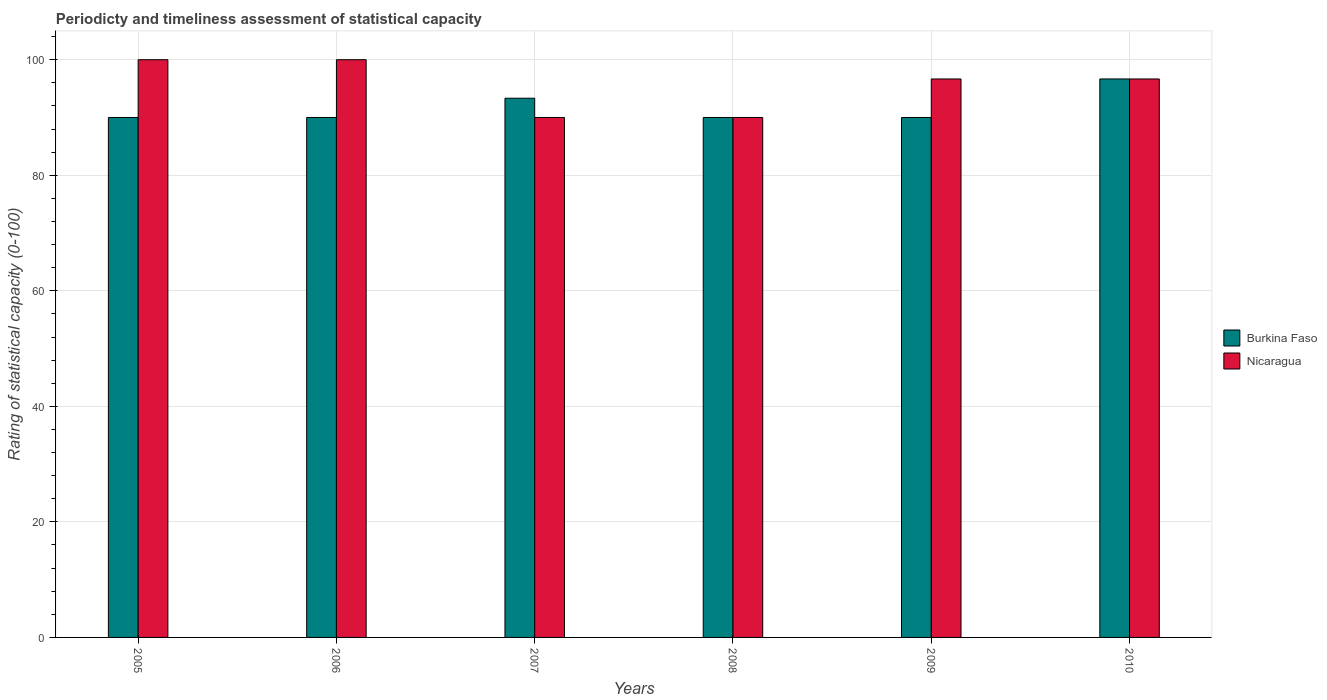Are the number of bars per tick equal to the number of legend labels?
Provide a short and direct response. Yes. Are the number of bars on each tick of the X-axis equal?
Keep it short and to the point. Yes. How many bars are there on the 1st tick from the right?
Offer a terse response. 2. What is the label of the 1st group of bars from the left?
Make the answer very short. 2005. What is the rating of statistical capacity in Burkina Faso in 2010?
Keep it short and to the point. 96.67. Across all years, what is the maximum rating of statistical capacity in Burkina Faso?
Ensure brevity in your answer.  96.67. Across all years, what is the minimum rating of statistical capacity in Nicaragua?
Keep it short and to the point. 90. What is the total rating of statistical capacity in Nicaragua in the graph?
Keep it short and to the point. 573.33. What is the difference between the rating of statistical capacity in Burkina Faso in 2005 and that in 2008?
Offer a very short reply. 0. What is the difference between the rating of statistical capacity in Burkina Faso in 2010 and the rating of statistical capacity in Nicaragua in 2009?
Make the answer very short. 0. What is the average rating of statistical capacity in Nicaragua per year?
Provide a short and direct response. 95.56. In the year 2008, what is the difference between the rating of statistical capacity in Nicaragua and rating of statistical capacity in Burkina Faso?
Give a very brief answer. 0. What is the difference between the highest and the second highest rating of statistical capacity in Nicaragua?
Provide a short and direct response. 0. What is the difference between the highest and the lowest rating of statistical capacity in Burkina Faso?
Ensure brevity in your answer.  6.67. In how many years, is the rating of statistical capacity in Nicaragua greater than the average rating of statistical capacity in Nicaragua taken over all years?
Ensure brevity in your answer.  4. Is the sum of the rating of statistical capacity in Nicaragua in 2008 and 2010 greater than the maximum rating of statistical capacity in Burkina Faso across all years?
Provide a succinct answer. Yes. What does the 1st bar from the left in 2008 represents?
Offer a terse response. Burkina Faso. What does the 1st bar from the right in 2005 represents?
Your response must be concise. Nicaragua. Are all the bars in the graph horizontal?
Keep it short and to the point. No. What is the difference between two consecutive major ticks on the Y-axis?
Provide a short and direct response. 20. Are the values on the major ticks of Y-axis written in scientific E-notation?
Your answer should be very brief. No. Does the graph contain any zero values?
Make the answer very short. No. Does the graph contain grids?
Provide a succinct answer. Yes. Where does the legend appear in the graph?
Your response must be concise. Center right. How are the legend labels stacked?
Provide a succinct answer. Vertical. What is the title of the graph?
Provide a succinct answer. Periodicty and timeliness assessment of statistical capacity. What is the label or title of the Y-axis?
Make the answer very short. Rating of statistical capacity (0-100). What is the Rating of statistical capacity (0-100) of Burkina Faso in 2005?
Your answer should be compact. 90. What is the Rating of statistical capacity (0-100) of Burkina Faso in 2006?
Provide a short and direct response. 90. What is the Rating of statistical capacity (0-100) of Nicaragua in 2006?
Your response must be concise. 100. What is the Rating of statistical capacity (0-100) of Burkina Faso in 2007?
Your answer should be very brief. 93.33. What is the Rating of statistical capacity (0-100) of Nicaragua in 2009?
Offer a terse response. 96.67. What is the Rating of statistical capacity (0-100) in Burkina Faso in 2010?
Provide a short and direct response. 96.67. What is the Rating of statistical capacity (0-100) of Nicaragua in 2010?
Provide a short and direct response. 96.67. Across all years, what is the maximum Rating of statistical capacity (0-100) in Burkina Faso?
Your response must be concise. 96.67. Across all years, what is the minimum Rating of statistical capacity (0-100) of Burkina Faso?
Your answer should be compact. 90. What is the total Rating of statistical capacity (0-100) of Burkina Faso in the graph?
Give a very brief answer. 550. What is the total Rating of statistical capacity (0-100) of Nicaragua in the graph?
Your answer should be compact. 573.33. What is the difference between the Rating of statistical capacity (0-100) of Nicaragua in 2005 and that in 2006?
Provide a succinct answer. 0. What is the difference between the Rating of statistical capacity (0-100) in Burkina Faso in 2005 and that in 2007?
Offer a terse response. -3.33. What is the difference between the Rating of statistical capacity (0-100) in Burkina Faso in 2005 and that in 2008?
Make the answer very short. 0. What is the difference between the Rating of statistical capacity (0-100) of Burkina Faso in 2005 and that in 2009?
Your response must be concise. 0. What is the difference between the Rating of statistical capacity (0-100) in Nicaragua in 2005 and that in 2009?
Keep it short and to the point. 3.33. What is the difference between the Rating of statistical capacity (0-100) of Burkina Faso in 2005 and that in 2010?
Keep it short and to the point. -6.67. What is the difference between the Rating of statistical capacity (0-100) of Nicaragua in 2005 and that in 2010?
Your answer should be compact. 3.33. What is the difference between the Rating of statistical capacity (0-100) of Nicaragua in 2006 and that in 2007?
Your response must be concise. 10. What is the difference between the Rating of statistical capacity (0-100) in Burkina Faso in 2006 and that in 2008?
Provide a succinct answer. 0. What is the difference between the Rating of statistical capacity (0-100) in Nicaragua in 2006 and that in 2009?
Provide a succinct answer. 3.33. What is the difference between the Rating of statistical capacity (0-100) in Burkina Faso in 2006 and that in 2010?
Provide a short and direct response. -6.67. What is the difference between the Rating of statistical capacity (0-100) in Burkina Faso in 2007 and that in 2008?
Offer a terse response. 3.33. What is the difference between the Rating of statistical capacity (0-100) in Nicaragua in 2007 and that in 2008?
Provide a succinct answer. 0. What is the difference between the Rating of statistical capacity (0-100) in Nicaragua in 2007 and that in 2009?
Make the answer very short. -6.67. What is the difference between the Rating of statistical capacity (0-100) of Burkina Faso in 2007 and that in 2010?
Your answer should be compact. -3.33. What is the difference between the Rating of statistical capacity (0-100) in Nicaragua in 2007 and that in 2010?
Your answer should be very brief. -6.67. What is the difference between the Rating of statistical capacity (0-100) in Nicaragua in 2008 and that in 2009?
Offer a very short reply. -6.67. What is the difference between the Rating of statistical capacity (0-100) of Burkina Faso in 2008 and that in 2010?
Make the answer very short. -6.67. What is the difference between the Rating of statistical capacity (0-100) of Nicaragua in 2008 and that in 2010?
Provide a succinct answer. -6.67. What is the difference between the Rating of statistical capacity (0-100) in Burkina Faso in 2009 and that in 2010?
Keep it short and to the point. -6.67. What is the difference between the Rating of statistical capacity (0-100) of Nicaragua in 2009 and that in 2010?
Your answer should be very brief. 0. What is the difference between the Rating of statistical capacity (0-100) of Burkina Faso in 2005 and the Rating of statistical capacity (0-100) of Nicaragua in 2007?
Provide a short and direct response. 0. What is the difference between the Rating of statistical capacity (0-100) in Burkina Faso in 2005 and the Rating of statistical capacity (0-100) in Nicaragua in 2009?
Your answer should be compact. -6.67. What is the difference between the Rating of statistical capacity (0-100) of Burkina Faso in 2005 and the Rating of statistical capacity (0-100) of Nicaragua in 2010?
Your answer should be very brief. -6.67. What is the difference between the Rating of statistical capacity (0-100) of Burkina Faso in 2006 and the Rating of statistical capacity (0-100) of Nicaragua in 2007?
Your answer should be compact. 0. What is the difference between the Rating of statistical capacity (0-100) in Burkina Faso in 2006 and the Rating of statistical capacity (0-100) in Nicaragua in 2009?
Offer a very short reply. -6.67. What is the difference between the Rating of statistical capacity (0-100) of Burkina Faso in 2006 and the Rating of statistical capacity (0-100) of Nicaragua in 2010?
Offer a very short reply. -6.67. What is the difference between the Rating of statistical capacity (0-100) of Burkina Faso in 2007 and the Rating of statistical capacity (0-100) of Nicaragua in 2008?
Provide a succinct answer. 3.33. What is the difference between the Rating of statistical capacity (0-100) in Burkina Faso in 2007 and the Rating of statistical capacity (0-100) in Nicaragua in 2009?
Your answer should be compact. -3.33. What is the difference between the Rating of statistical capacity (0-100) of Burkina Faso in 2008 and the Rating of statistical capacity (0-100) of Nicaragua in 2009?
Provide a succinct answer. -6.67. What is the difference between the Rating of statistical capacity (0-100) of Burkina Faso in 2008 and the Rating of statistical capacity (0-100) of Nicaragua in 2010?
Your response must be concise. -6.67. What is the difference between the Rating of statistical capacity (0-100) of Burkina Faso in 2009 and the Rating of statistical capacity (0-100) of Nicaragua in 2010?
Provide a succinct answer. -6.67. What is the average Rating of statistical capacity (0-100) of Burkina Faso per year?
Provide a short and direct response. 91.67. What is the average Rating of statistical capacity (0-100) in Nicaragua per year?
Make the answer very short. 95.56. In the year 2007, what is the difference between the Rating of statistical capacity (0-100) in Burkina Faso and Rating of statistical capacity (0-100) in Nicaragua?
Provide a short and direct response. 3.33. In the year 2008, what is the difference between the Rating of statistical capacity (0-100) in Burkina Faso and Rating of statistical capacity (0-100) in Nicaragua?
Provide a short and direct response. 0. In the year 2009, what is the difference between the Rating of statistical capacity (0-100) in Burkina Faso and Rating of statistical capacity (0-100) in Nicaragua?
Offer a very short reply. -6.67. What is the ratio of the Rating of statistical capacity (0-100) in Nicaragua in 2005 to that in 2006?
Make the answer very short. 1. What is the ratio of the Rating of statistical capacity (0-100) in Nicaragua in 2005 to that in 2007?
Your answer should be very brief. 1.11. What is the ratio of the Rating of statistical capacity (0-100) of Burkina Faso in 2005 to that in 2008?
Provide a short and direct response. 1. What is the ratio of the Rating of statistical capacity (0-100) in Nicaragua in 2005 to that in 2008?
Offer a terse response. 1.11. What is the ratio of the Rating of statistical capacity (0-100) in Nicaragua in 2005 to that in 2009?
Your response must be concise. 1.03. What is the ratio of the Rating of statistical capacity (0-100) in Nicaragua in 2005 to that in 2010?
Your answer should be very brief. 1.03. What is the ratio of the Rating of statistical capacity (0-100) of Nicaragua in 2006 to that in 2007?
Keep it short and to the point. 1.11. What is the ratio of the Rating of statistical capacity (0-100) in Nicaragua in 2006 to that in 2008?
Your answer should be compact. 1.11. What is the ratio of the Rating of statistical capacity (0-100) of Nicaragua in 2006 to that in 2009?
Offer a terse response. 1.03. What is the ratio of the Rating of statistical capacity (0-100) in Burkina Faso in 2006 to that in 2010?
Your response must be concise. 0.93. What is the ratio of the Rating of statistical capacity (0-100) in Nicaragua in 2006 to that in 2010?
Provide a succinct answer. 1.03. What is the ratio of the Rating of statistical capacity (0-100) in Burkina Faso in 2007 to that in 2008?
Provide a short and direct response. 1.04. What is the ratio of the Rating of statistical capacity (0-100) of Nicaragua in 2007 to that in 2008?
Make the answer very short. 1. What is the ratio of the Rating of statistical capacity (0-100) of Burkina Faso in 2007 to that in 2009?
Your answer should be compact. 1.04. What is the ratio of the Rating of statistical capacity (0-100) of Burkina Faso in 2007 to that in 2010?
Your response must be concise. 0.97. What is the ratio of the Rating of statistical capacity (0-100) in Nicaragua in 2007 to that in 2010?
Provide a short and direct response. 0.93. What is the ratio of the Rating of statistical capacity (0-100) of Burkina Faso in 2008 to that in 2009?
Your answer should be very brief. 1. What is the ratio of the Rating of statistical capacity (0-100) in Burkina Faso in 2008 to that in 2010?
Offer a terse response. 0.93. What is the ratio of the Rating of statistical capacity (0-100) of Burkina Faso in 2009 to that in 2010?
Offer a very short reply. 0.93. What is the ratio of the Rating of statistical capacity (0-100) of Nicaragua in 2009 to that in 2010?
Provide a succinct answer. 1. What is the difference between the highest and the second highest Rating of statistical capacity (0-100) in Nicaragua?
Provide a succinct answer. 0. What is the difference between the highest and the lowest Rating of statistical capacity (0-100) of Burkina Faso?
Make the answer very short. 6.67. What is the difference between the highest and the lowest Rating of statistical capacity (0-100) of Nicaragua?
Your answer should be compact. 10. 